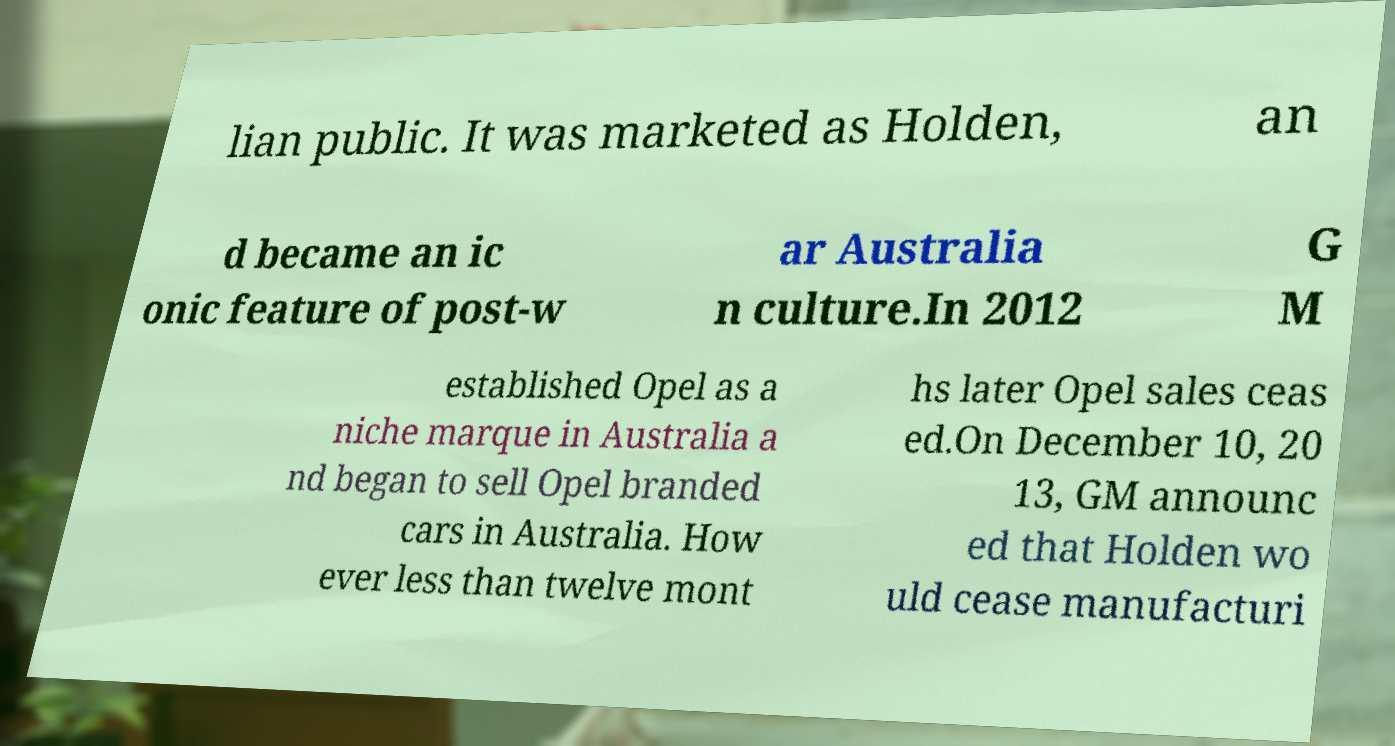Could you assist in decoding the text presented in this image and type it out clearly? lian public. It was marketed as Holden, an d became an ic onic feature of post-w ar Australia n culture.In 2012 G M established Opel as a niche marque in Australia a nd began to sell Opel branded cars in Australia. How ever less than twelve mont hs later Opel sales ceas ed.On December 10, 20 13, GM announc ed that Holden wo uld cease manufacturi 